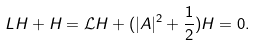Convert formula to latex. <formula><loc_0><loc_0><loc_500><loc_500>L H + H = \mathcal { L } H + ( | A | ^ { 2 } + \frac { 1 } { 2 } ) H = 0 .</formula> 